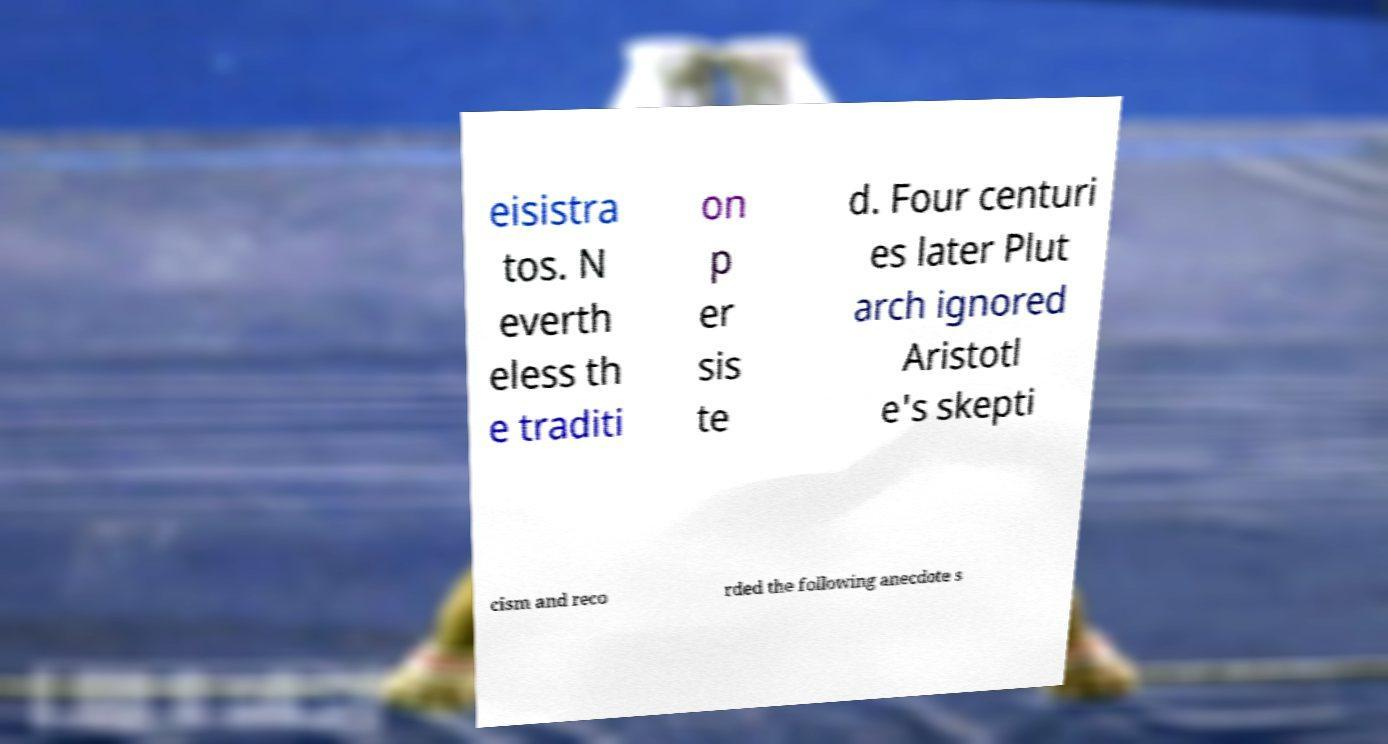Please identify and transcribe the text found in this image. eisistra tos. N everth eless th e traditi on p er sis te d. Four centuri es later Plut arch ignored Aristotl e's skepti cism and reco rded the following anecdote s 